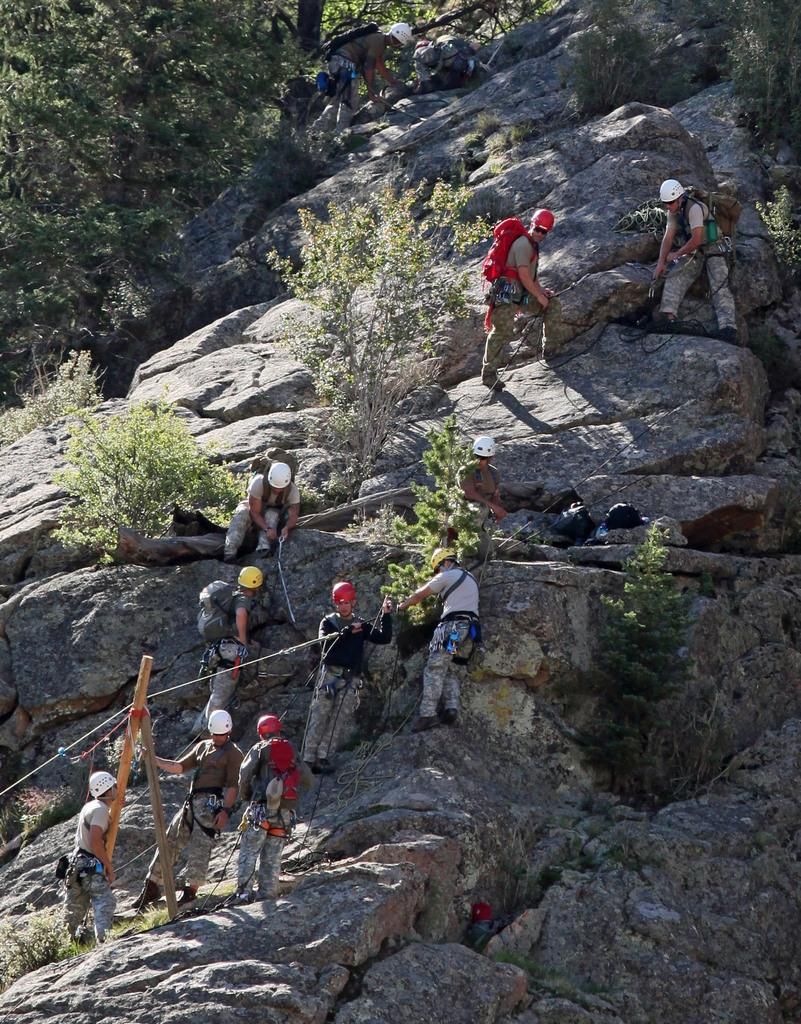What are the people in the image wearing on their heads? The people in the image are wearing helmets. What type of objects can be seen in the image besides the people? There are bags, wooden poles, a rope, a rock, plants, and trees visible in the image. What might be used to secure or connect objects in the image? The rope in the image might be used to secure or connect objects. What type of vegetation is present in the image? Plants and trees are present in the image. What type of plate is being used to serve the food in the image? There is no plate or food present in the image; it features people wearing helmets and various objects. How does the faucet in the image contribute to the overall scene? There is no faucet present in the image. 